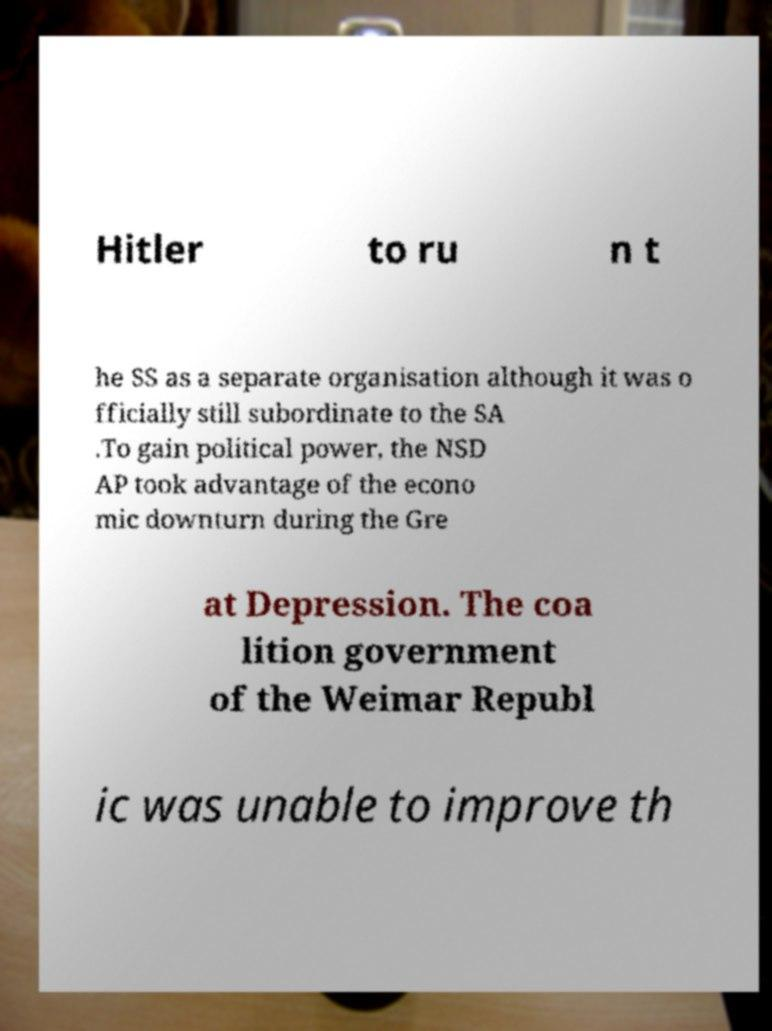There's text embedded in this image that I need extracted. Can you transcribe it verbatim? Hitler to ru n t he SS as a separate organisation although it was o fficially still subordinate to the SA .To gain political power, the NSD AP took advantage of the econo mic downturn during the Gre at Depression. The coa lition government of the Weimar Republ ic was unable to improve th 